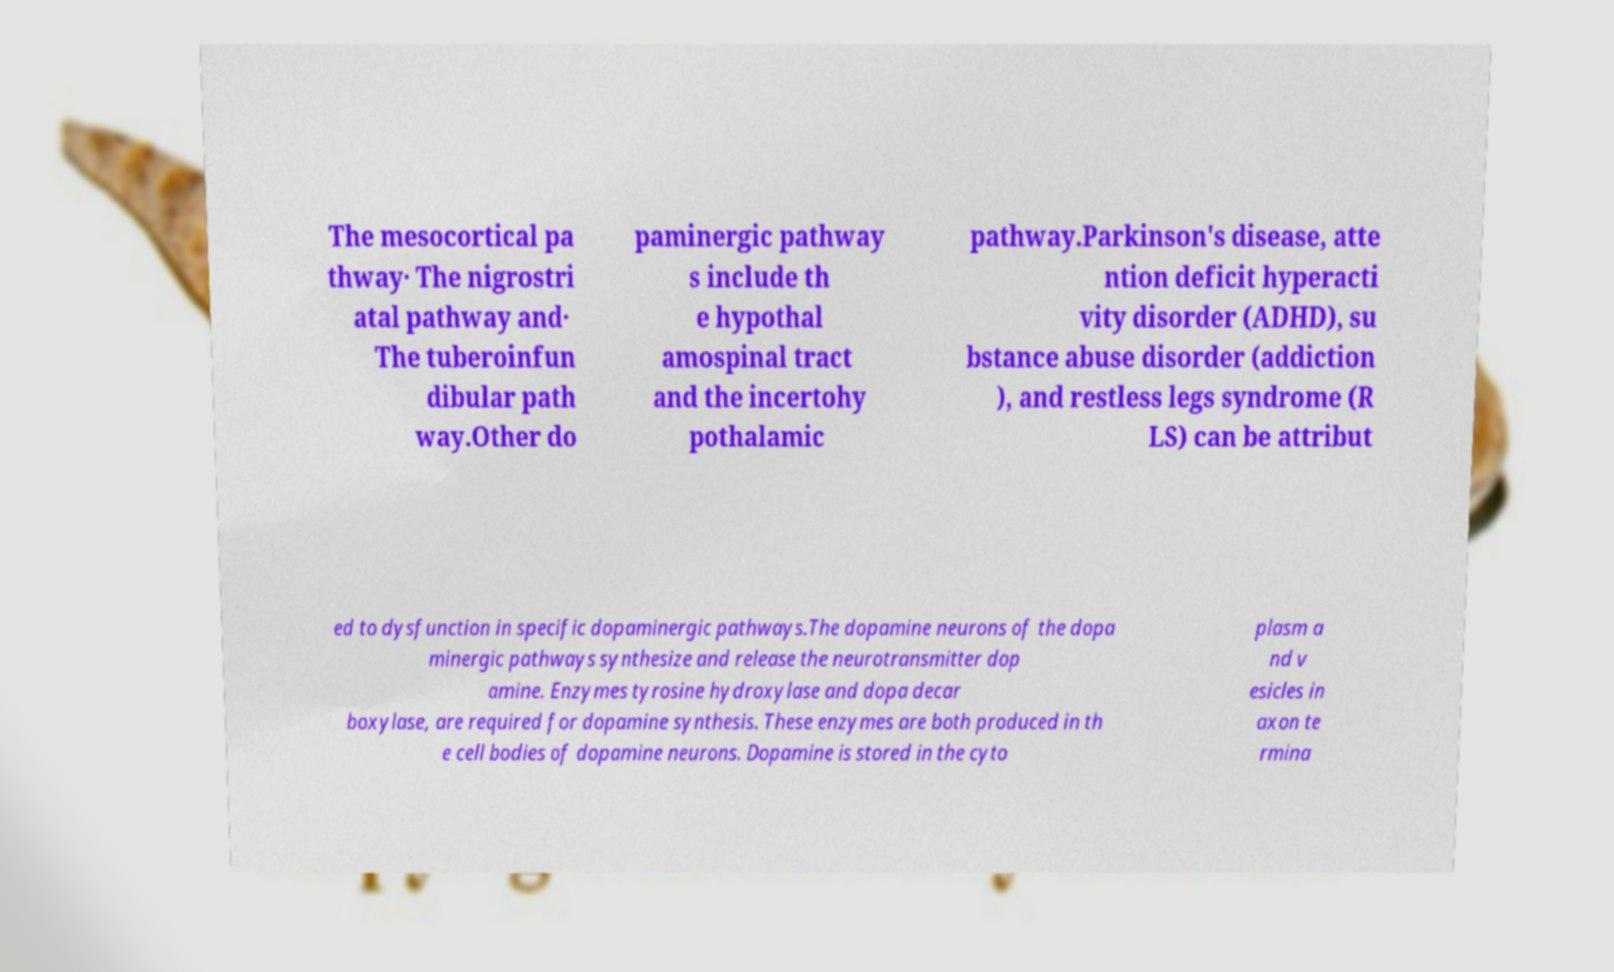Can you read and provide the text displayed in the image?This photo seems to have some interesting text. Can you extract and type it out for me? The mesocortical pa thway· The nigrostri atal pathway and· The tuberoinfun dibular path way.Other do paminergic pathway s include th e hypothal amospinal tract and the incertohy pothalamic pathway.Parkinson's disease, atte ntion deficit hyperacti vity disorder (ADHD), su bstance abuse disorder (addiction ), and restless legs syndrome (R LS) can be attribut ed to dysfunction in specific dopaminergic pathways.The dopamine neurons of the dopa minergic pathways synthesize and release the neurotransmitter dop amine. Enzymes tyrosine hydroxylase and dopa decar boxylase, are required for dopamine synthesis. These enzymes are both produced in th e cell bodies of dopamine neurons. Dopamine is stored in the cyto plasm a nd v esicles in axon te rmina 